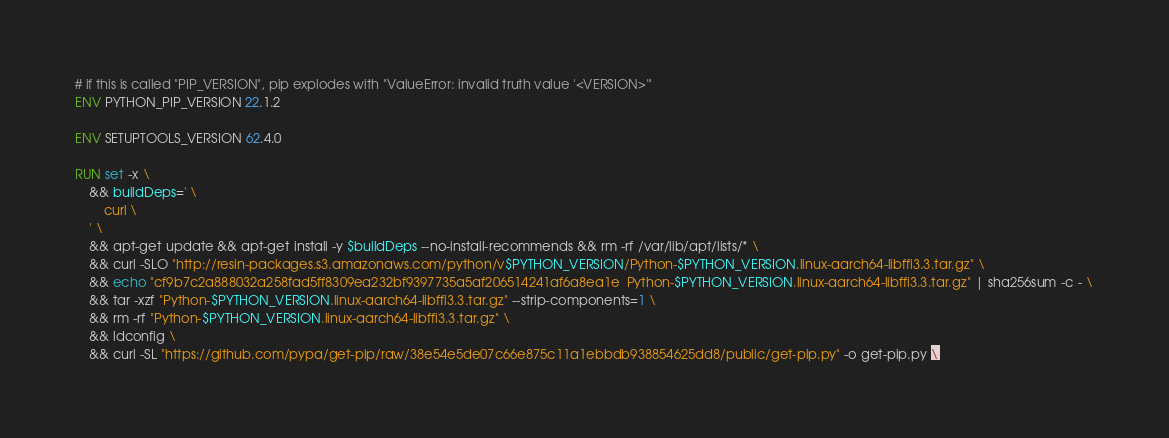Convert code to text. <code><loc_0><loc_0><loc_500><loc_500><_Dockerfile_># if this is called "PIP_VERSION", pip explodes with "ValueError: invalid truth value '<VERSION>'"
ENV PYTHON_PIP_VERSION 22.1.2

ENV SETUPTOOLS_VERSION 62.4.0

RUN set -x \
	&& buildDeps=' \
		curl \
	' \
	&& apt-get update && apt-get install -y $buildDeps --no-install-recommends && rm -rf /var/lib/apt/lists/* \
	&& curl -SLO "http://resin-packages.s3.amazonaws.com/python/v$PYTHON_VERSION/Python-$PYTHON_VERSION.linux-aarch64-libffi3.3.tar.gz" \
	&& echo "cf9b7c2a888032a258fad5ff8309ea232bf9397735a5af206514241af6a8ea1e  Python-$PYTHON_VERSION.linux-aarch64-libffi3.3.tar.gz" | sha256sum -c - \
	&& tar -xzf "Python-$PYTHON_VERSION.linux-aarch64-libffi3.3.tar.gz" --strip-components=1 \
	&& rm -rf "Python-$PYTHON_VERSION.linux-aarch64-libffi3.3.tar.gz" \
	&& ldconfig \
	&& curl -SL "https://github.com/pypa/get-pip/raw/38e54e5de07c66e875c11a1ebbdb938854625dd8/public/get-pip.py" -o get-pip.py \</code> 